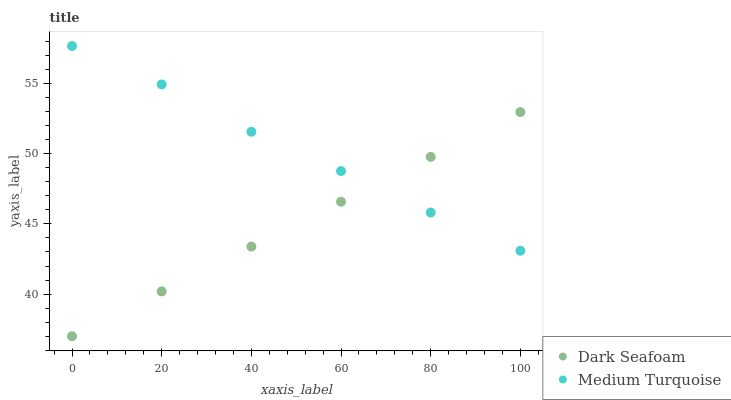Does Dark Seafoam have the minimum area under the curve?
Answer yes or no. Yes. Does Medium Turquoise have the maximum area under the curve?
Answer yes or no. Yes. Does Medium Turquoise have the minimum area under the curve?
Answer yes or no. No. Is Dark Seafoam the smoothest?
Answer yes or no. Yes. Is Medium Turquoise the roughest?
Answer yes or no. Yes. Is Medium Turquoise the smoothest?
Answer yes or no. No. Does Dark Seafoam have the lowest value?
Answer yes or no. Yes. Does Medium Turquoise have the lowest value?
Answer yes or no. No. Does Medium Turquoise have the highest value?
Answer yes or no. Yes. Does Medium Turquoise intersect Dark Seafoam?
Answer yes or no. Yes. Is Medium Turquoise less than Dark Seafoam?
Answer yes or no. No. Is Medium Turquoise greater than Dark Seafoam?
Answer yes or no. No. 